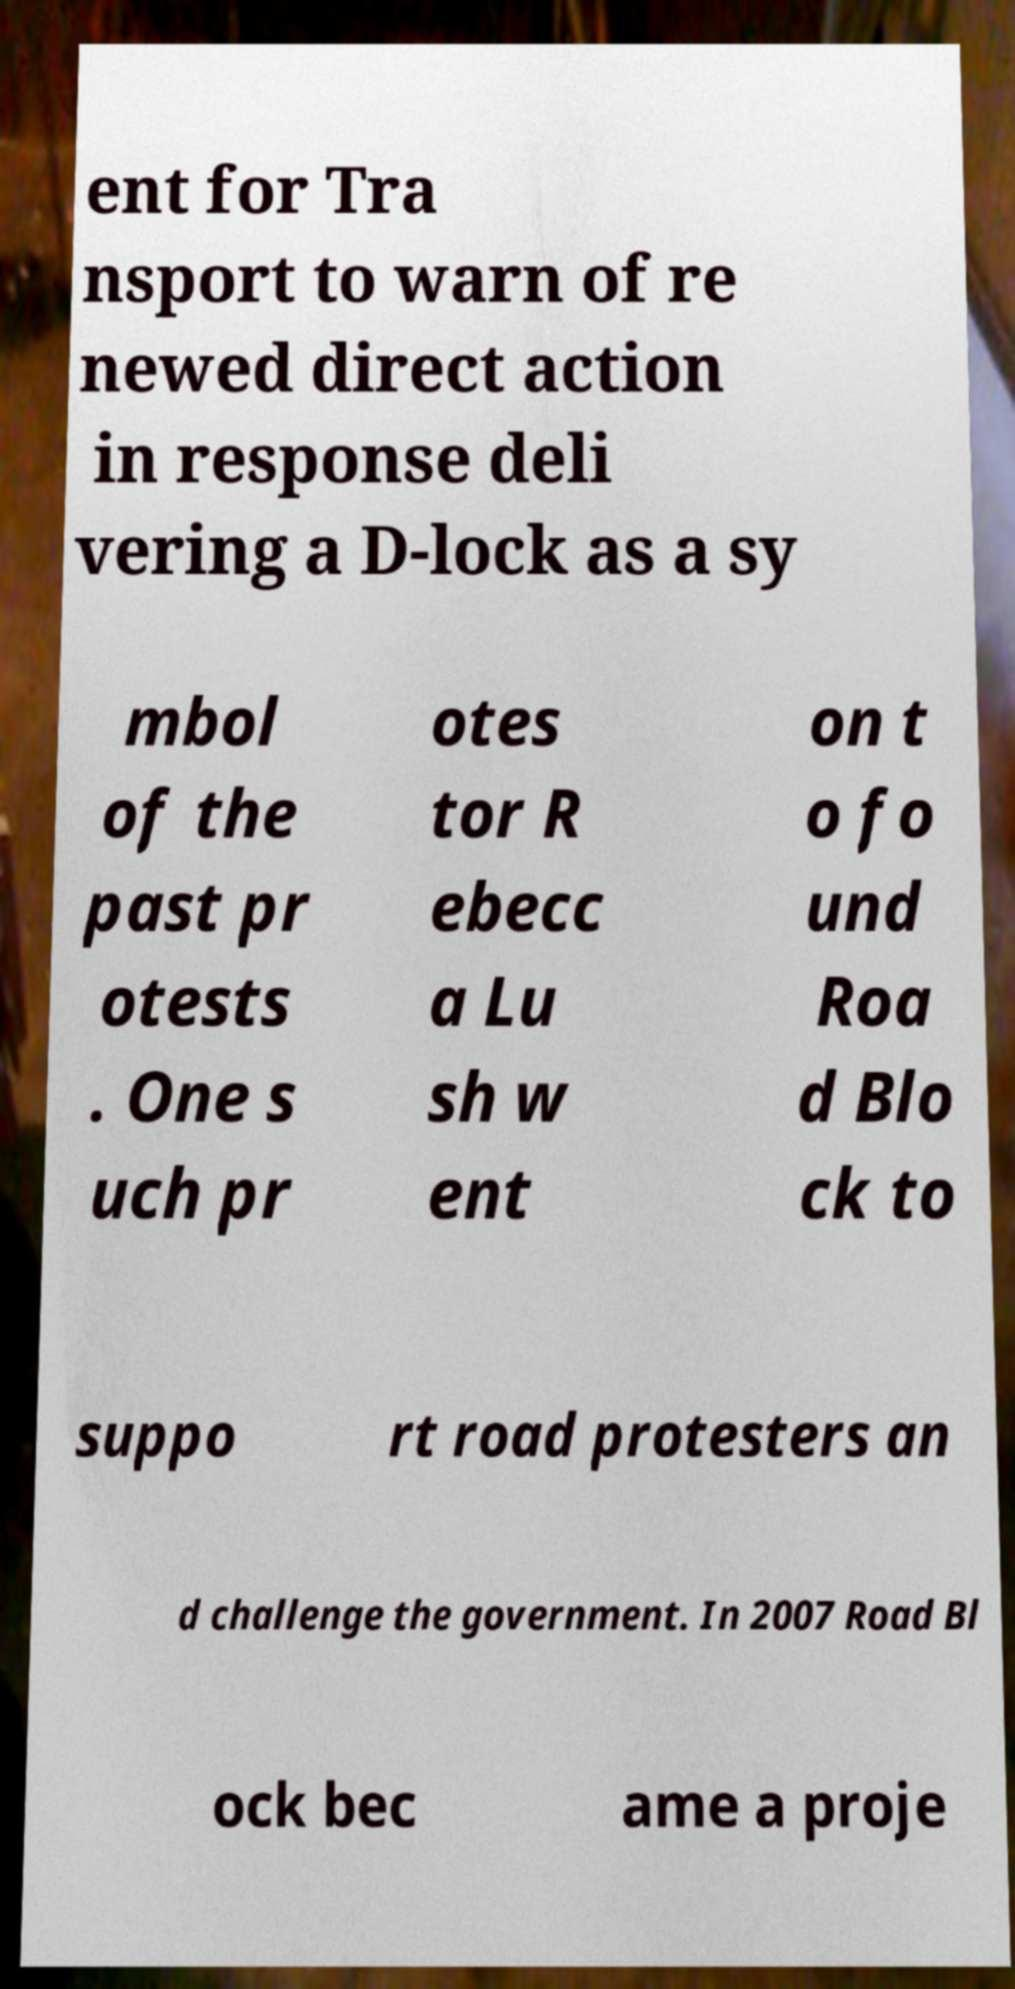Please read and relay the text visible in this image. What does it say? ent for Tra nsport to warn of re newed direct action in response deli vering a D-lock as a sy mbol of the past pr otests . One s uch pr otes tor R ebecc a Lu sh w ent on t o fo und Roa d Blo ck to suppo rt road protesters an d challenge the government. In 2007 Road Bl ock bec ame a proje 